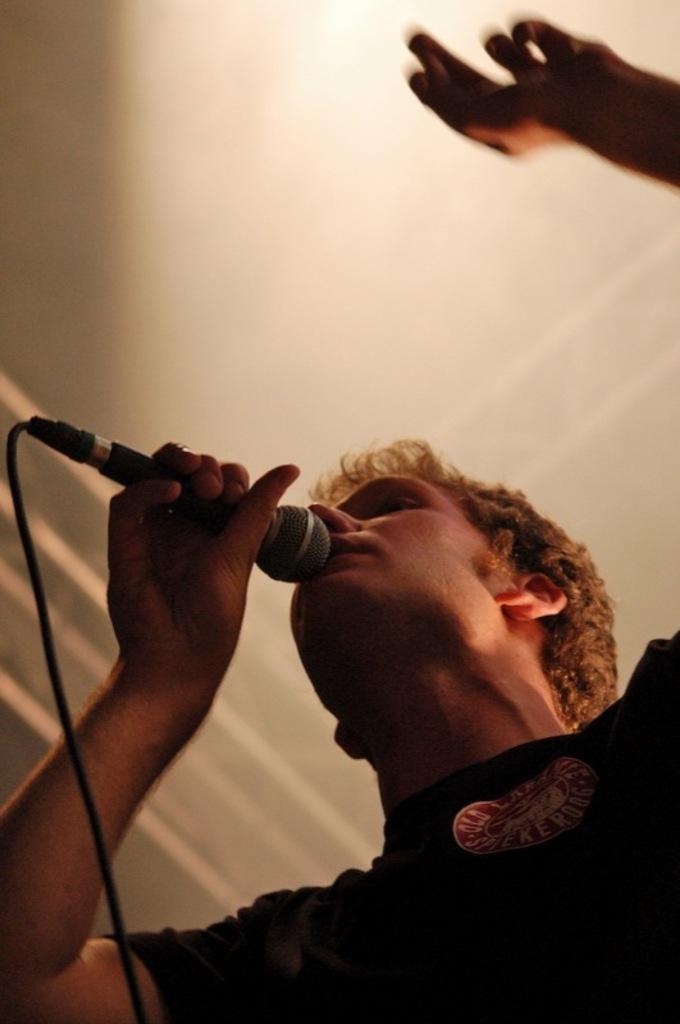Can you describe this image briefly? In this image I can see a man singing a song using a mike. This is a mike with a wire attached to it. 